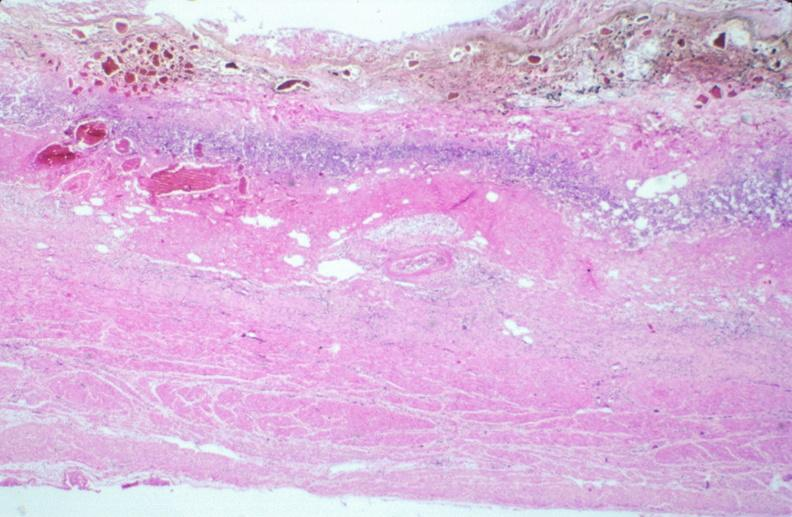does slide show stomach, necrotizing esophagitis and gastritis, sulfuric acid ingested as suicide attempt?
Answer the question using a single word or phrase. No 